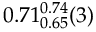Convert formula to latex. <formula><loc_0><loc_0><loc_500><loc_500>0 . 7 1 _ { 0 . 6 5 } ^ { 0 . 7 4 } ( 3 )</formula> 